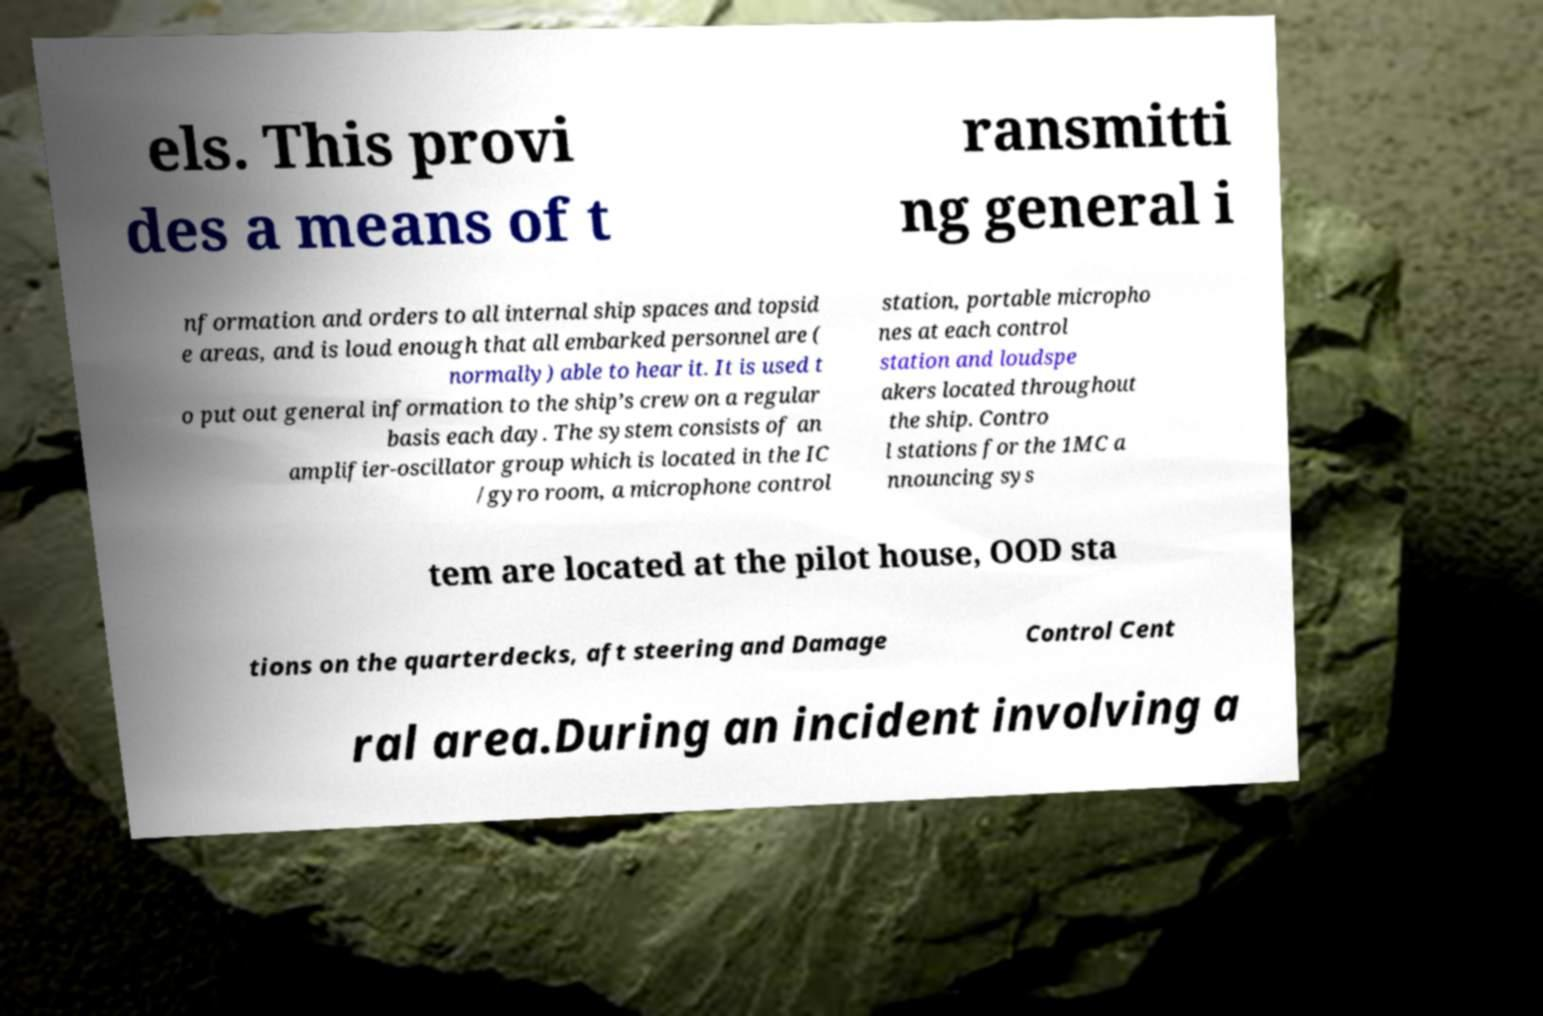Please read and relay the text visible in this image. What does it say? els. This provi des a means of t ransmitti ng general i nformation and orders to all internal ship spaces and topsid e areas, and is loud enough that all embarked personnel are ( normally) able to hear it. It is used t o put out general information to the ship’s crew on a regular basis each day. The system consists of an amplifier-oscillator group which is located in the IC /gyro room, a microphone control station, portable micropho nes at each control station and loudspe akers located throughout the ship. Contro l stations for the 1MC a nnouncing sys tem are located at the pilot house, OOD sta tions on the quarterdecks, aft steering and Damage Control Cent ral area.During an incident involving a 